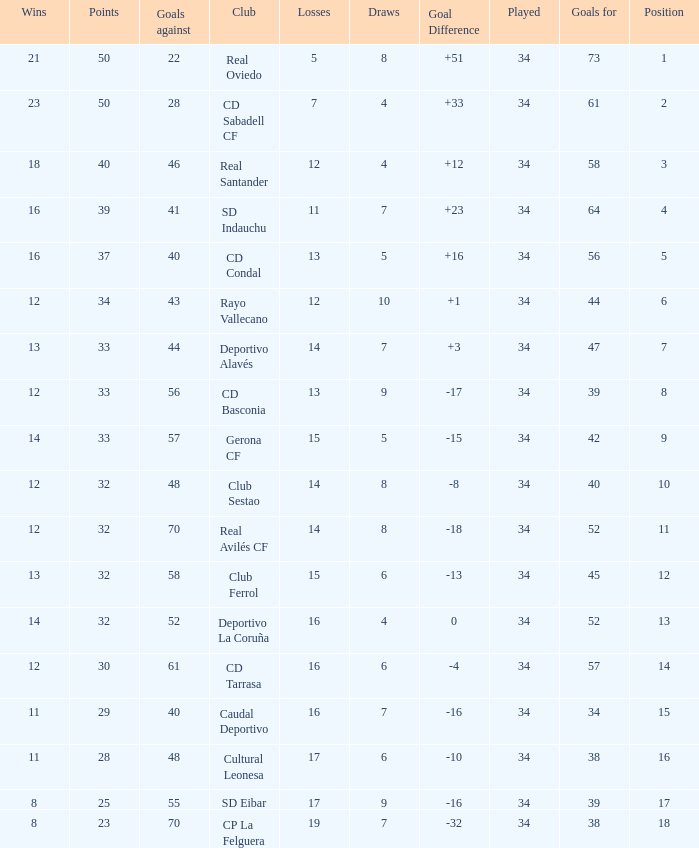Which Wins have a Goal Difference larger than 0, and Goals against larger than 40, and a Position smaller than 6, and a Club of sd indauchu? 16.0. 